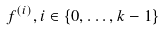<formula> <loc_0><loc_0><loc_500><loc_500>f ^ { ( i ) } , i \in \{ 0 , \dots , k - 1 \}</formula> 